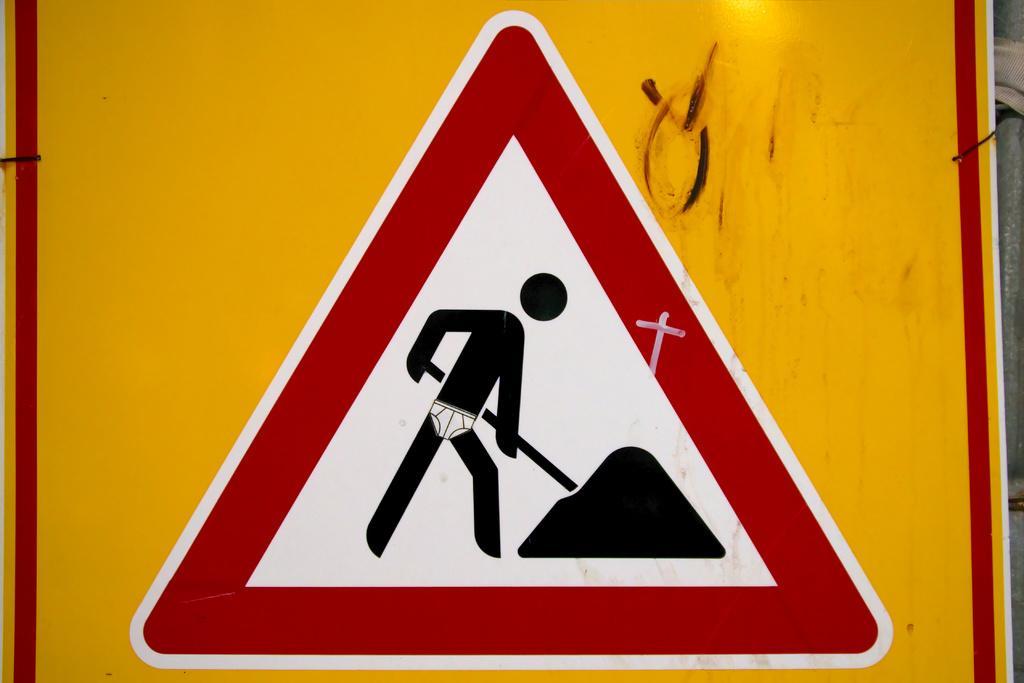Could you give a brief overview of what you see in this image? This image is taken outdoors. In this image there is a sign board. 